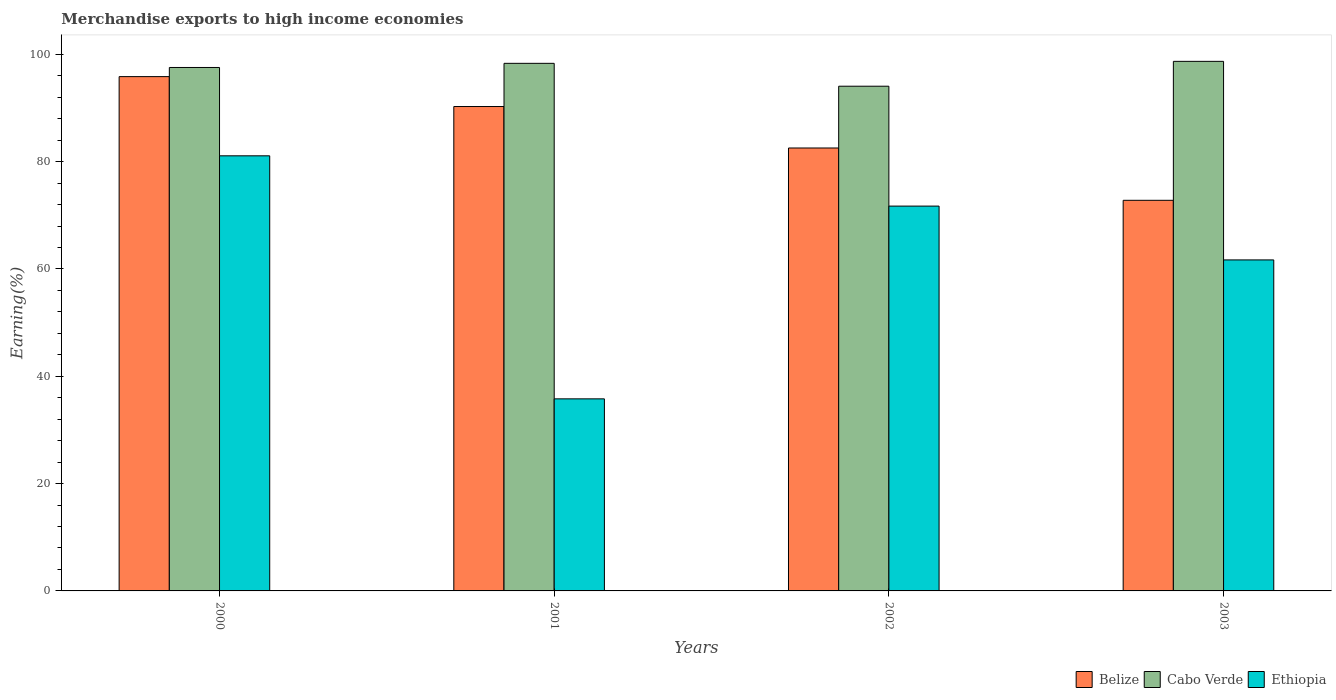Are the number of bars per tick equal to the number of legend labels?
Provide a short and direct response. Yes. What is the label of the 2nd group of bars from the left?
Ensure brevity in your answer.  2001. In how many cases, is the number of bars for a given year not equal to the number of legend labels?
Your answer should be very brief. 0. What is the percentage of amount earned from merchandise exports in Belize in 2002?
Ensure brevity in your answer.  82.54. Across all years, what is the maximum percentage of amount earned from merchandise exports in Belize?
Provide a short and direct response. 95.84. Across all years, what is the minimum percentage of amount earned from merchandise exports in Cabo Verde?
Keep it short and to the point. 94.05. What is the total percentage of amount earned from merchandise exports in Ethiopia in the graph?
Your response must be concise. 250.26. What is the difference between the percentage of amount earned from merchandise exports in Cabo Verde in 2001 and that in 2002?
Keep it short and to the point. 4.26. What is the difference between the percentage of amount earned from merchandise exports in Cabo Verde in 2000 and the percentage of amount earned from merchandise exports in Belize in 2001?
Give a very brief answer. 7.28. What is the average percentage of amount earned from merchandise exports in Belize per year?
Your answer should be compact. 85.36. In the year 2000, what is the difference between the percentage of amount earned from merchandise exports in Cabo Verde and percentage of amount earned from merchandise exports in Ethiopia?
Your response must be concise. 16.46. What is the ratio of the percentage of amount earned from merchandise exports in Cabo Verde in 2000 to that in 2003?
Give a very brief answer. 0.99. What is the difference between the highest and the second highest percentage of amount earned from merchandise exports in Ethiopia?
Make the answer very short. 9.37. What is the difference between the highest and the lowest percentage of amount earned from merchandise exports in Cabo Verde?
Offer a very short reply. 4.63. In how many years, is the percentage of amount earned from merchandise exports in Belize greater than the average percentage of amount earned from merchandise exports in Belize taken over all years?
Provide a succinct answer. 2. What does the 2nd bar from the left in 2003 represents?
Make the answer very short. Cabo Verde. What does the 1st bar from the right in 2001 represents?
Offer a very short reply. Ethiopia. Are all the bars in the graph horizontal?
Make the answer very short. No. Does the graph contain any zero values?
Offer a terse response. No. Does the graph contain grids?
Make the answer very short. No. Where does the legend appear in the graph?
Your answer should be compact. Bottom right. How are the legend labels stacked?
Offer a terse response. Horizontal. What is the title of the graph?
Give a very brief answer. Merchandise exports to high income economies. Does "Antigua and Barbuda" appear as one of the legend labels in the graph?
Offer a terse response. No. What is the label or title of the X-axis?
Your answer should be very brief. Years. What is the label or title of the Y-axis?
Provide a succinct answer. Earning(%). What is the Earning(%) of Belize in 2000?
Ensure brevity in your answer.  95.84. What is the Earning(%) of Cabo Verde in 2000?
Offer a terse response. 97.54. What is the Earning(%) of Ethiopia in 2000?
Offer a terse response. 81.08. What is the Earning(%) of Belize in 2001?
Give a very brief answer. 90.27. What is the Earning(%) of Cabo Verde in 2001?
Ensure brevity in your answer.  98.31. What is the Earning(%) of Ethiopia in 2001?
Keep it short and to the point. 35.79. What is the Earning(%) in Belize in 2002?
Offer a terse response. 82.54. What is the Earning(%) of Cabo Verde in 2002?
Offer a very short reply. 94.05. What is the Earning(%) in Ethiopia in 2002?
Your answer should be compact. 71.71. What is the Earning(%) in Belize in 2003?
Make the answer very short. 72.79. What is the Earning(%) of Cabo Verde in 2003?
Offer a terse response. 98.68. What is the Earning(%) of Ethiopia in 2003?
Provide a short and direct response. 61.68. Across all years, what is the maximum Earning(%) in Belize?
Offer a terse response. 95.84. Across all years, what is the maximum Earning(%) in Cabo Verde?
Your answer should be compact. 98.68. Across all years, what is the maximum Earning(%) in Ethiopia?
Provide a succinct answer. 81.08. Across all years, what is the minimum Earning(%) in Belize?
Provide a short and direct response. 72.79. Across all years, what is the minimum Earning(%) of Cabo Verde?
Your response must be concise. 94.05. Across all years, what is the minimum Earning(%) in Ethiopia?
Make the answer very short. 35.79. What is the total Earning(%) in Belize in the graph?
Your answer should be very brief. 341.43. What is the total Earning(%) of Cabo Verde in the graph?
Offer a very short reply. 388.59. What is the total Earning(%) of Ethiopia in the graph?
Your response must be concise. 250.26. What is the difference between the Earning(%) in Belize in 2000 and that in 2001?
Your response must be concise. 5.57. What is the difference between the Earning(%) in Cabo Verde in 2000 and that in 2001?
Keep it short and to the point. -0.77. What is the difference between the Earning(%) in Ethiopia in 2000 and that in 2001?
Make the answer very short. 45.29. What is the difference between the Earning(%) in Belize in 2000 and that in 2002?
Offer a terse response. 13.3. What is the difference between the Earning(%) of Cabo Verde in 2000 and that in 2002?
Give a very brief answer. 3.49. What is the difference between the Earning(%) in Ethiopia in 2000 and that in 2002?
Keep it short and to the point. 9.37. What is the difference between the Earning(%) of Belize in 2000 and that in 2003?
Your response must be concise. 23.05. What is the difference between the Earning(%) in Cabo Verde in 2000 and that in 2003?
Give a very brief answer. -1.14. What is the difference between the Earning(%) in Ethiopia in 2000 and that in 2003?
Keep it short and to the point. 19.4. What is the difference between the Earning(%) of Belize in 2001 and that in 2002?
Your answer should be compact. 7.73. What is the difference between the Earning(%) in Cabo Verde in 2001 and that in 2002?
Your answer should be compact. 4.26. What is the difference between the Earning(%) of Ethiopia in 2001 and that in 2002?
Keep it short and to the point. -35.92. What is the difference between the Earning(%) in Belize in 2001 and that in 2003?
Make the answer very short. 17.48. What is the difference between the Earning(%) of Cabo Verde in 2001 and that in 2003?
Give a very brief answer. -0.37. What is the difference between the Earning(%) in Ethiopia in 2001 and that in 2003?
Keep it short and to the point. -25.89. What is the difference between the Earning(%) in Belize in 2002 and that in 2003?
Your response must be concise. 9.75. What is the difference between the Earning(%) of Cabo Verde in 2002 and that in 2003?
Your answer should be very brief. -4.63. What is the difference between the Earning(%) of Ethiopia in 2002 and that in 2003?
Offer a very short reply. 10.03. What is the difference between the Earning(%) of Belize in 2000 and the Earning(%) of Cabo Verde in 2001?
Keep it short and to the point. -2.47. What is the difference between the Earning(%) in Belize in 2000 and the Earning(%) in Ethiopia in 2001?
Your response must be concise. 60.05. What is the difference between the Earning(%) in Cabo Verde in 2000 and the Earning(%) in Ethiopia in 2001?
Offer a terse response. 61.75. What is the difference between the Earning(%) of Belize in 2000 and the Earning(%) of Cabo Verde in 2002?
Your response must be concise. 1.79. What is the difference between the Earning(%) in Belize in 2000 and the Earning(%) in Ethiopia in 2002?
Your response must be concise. 24.13. What is the difference between the Earning(%) of Cabo Verde in 2000 and the Earning(%) of Ethiopia in 2002?
Offer a terse response. 25.83. What is the difference between the Earning(%) of Belize in 2000 and the Earning(%) of Cabo Verde in 2003?
Provide a succinct answer. -2.84. What is the difference between the Earning(%) of Belize in 2000 and the Earning(%) of Ethiopia in 2003?
Give a very brief answer. 34.16. What is the difference between the Earning(%) of Cabo Verde in 2000 and the Earning(%) of Ethiopia in 2003?
Your answer should be compact. 35.86. What is the difference between the Earning(%) in Belize in 2001 and the Earning(%) in Cabo Verde in 2002?
Your answer should be very brief. -3.79. What is the difference between the Earning(%) in Belize in 2001 and the Earning(%) in Ethiopia in 2002?
Make the answer very short. 18.56. What is the difference between the Earning(%) in Cabo Verde in 2001 and the Earning(%) in Ethiopia in 2002?
Provide a succinct answer. 26.6. What is the difference between the Earning(%) of Belize in 2001 and the Earning(%) of Cabo Verde in 2003?
Provide a succinct answer. -8.42. What is the difference between the Earning(%) in Belize in 2001 and the Earning(%) in Ethiopia in 2003?
Make the answer very short. 28.59. What is the difference between the Earning(%) in Cabo Verde in 2001 and the Earning(%) in Ethiopia in 2003?
Your answer should be very brief. 36.63. What is the difference between the Earning(%) in Belize in 2002 and the Earning(%) in Cabo Verde in 2003?
Your answer should be compact. -16.14. What is the difference between the Earning(%) in Belize in 2002 and the Earning(%) in Ethiopia in 2003?
Provide a succinct answer. 20.86. What is the difference between the Earning(%) in Cabo Verde in 2002 and the Earning(%) in Ethiopia in 2003?
Ensure brevity in your answer.  32.37. What is the average Earning(%) of Belize per year?
Make the answer very short. 85.36. What is the average Earning(%) of Cabo Verde per year?
Your response must be concise. 97.15. What is the average Earning(%) in Ethiopia per year?
Make the answer very short. 62.57. In the year 2000, what is the difference between the Earning(%) in Belize and Earning(%) in Cabo Verde?
Provide a succinct answer. -1.7. In the year 2000, what is the difference between the Earning(%) in Belize and Earning(%) in Ethiopia?
Your answer should be very brief. 14.76. In the year 2000, what is the difference between the Earning(%) in Cabo Verde and Earning(%) in Ethiopia?
Make the answer very short. 16.46. In the year 2001, what is the difference between the Earning(%) of Belize and Earning(%) of Cabo Verde?
Keep it short and to the point. -8.05. In the year 2001, what is the difference between the Earning(%) in Belize and Earning(%) in Ethiopia?
Provide a short and direct response. 54.48. In the year 2001, what is the difference between the Earning(%) of Cabo Verde and Earning(%) of Ethiopia?
Give a very brief answer. 62.52. In the year 2002, what is the difference between the Earning(%) in Belize and Earning(%) in Cabo Verde?
Your answer should be compact. -11.51. In the year 2002, what is the difference between the Earning(%) in Belize and Earning(%) in Ethiopia?
Offer a very short reply. 10.83. In the year 2002, what is the difference between the Earning(%) of Cabo Verde and Earning(%) of Ethiopia?
Offer a very short reply. 22.34. In the year 2003, what is the difference between the Earning(%) in Belize and Earning(%) in Cabo Verde?
Offer a terse response. -25.89. In the year 2003, what is the difference between the Earning(%) of Belize and Earning(%) of Ethiopia?
Provide a short and direct response. 11.11. In the year 2003, what is the difference between the Earning(%) of Cabo Verde and Earning(%) of Ethiopia?
Ensure brevity in your answer.  37. What is the ratio of the Earning(%) in Belize in 2000 to that in 2001?
Your answer should be very brief. 1.06. What is the ratio of the Earning(%) of Ethiopia in 2000 to that in 2001?
Provide a short and direct response. 2.27. What is the ratio of the Earning(%) of Belize in 2000 to that in 2002?
Offer a very short reply. 1.16. What is the ratio of the Earning(%) of Cabo Verde in 2000 to that in 2002?
Offer a very short reply. 1.04. What is the ratio of the Earning(%) of Ethiopia in 2000 to that in 2002?
Your answer should be compact. 1.13. What is the ratio of the Earning(%) of Belize in 2000 to that in 2003?
Your answer should be compact. 1.32. What is the ratio of the Earning(%) of Cabo Verde in 2000 to that in 2003?
Your answer should be compact. 0.99. What is the ratio of the Earning(%) in Ethiopia in 2000 to that in 2003?
Provide a short and direct response. 1.31. What is the ratio of the Earning(%) in Belize in 2001 to that in 2002?
Give a very brief answer. 1.09. What is the ratio of the Earning(%) in Cabo Verde in 2001 to that in 2002?
Keep it short and to the point. 1.05. What is the ratio of the Earning(%) in Ethiopia in 2001 to that in 2002?
Your answer should be very brief. 0.5. What is the ratio of the Earning(%) of Belize in 2001 to that in 2003?
Your answer should be compact. 1.24. What is the ratio of the Earning(%) of Cabo Verde in 2001 to that in 2003?
Make the answer very short. 1. What is the ratio of the Earning(%) of Ethiopia in 2001 to that in 2003?
Provide a succinct answer. 0.58. What is the ratio of the Earning(%) in Belize in 2002 to that in 2003?
Provide a short and direct response. 1.13. What is the ratio of the Earning(%) of Cabo Verde in 2002 to that in 2003?
Your response must be concise. 0.95. What is the ratio of the Earning(%) in Ethiopia in 2002 to that in 2003?
Keep it short and to the point. 1.16. What is the difference between the highest and the second highest Earning(%) of Belize?
Provide a succinct answer. 5.57. What is the difference between the highest and the second highest Earning(%) of Cabo Verde?
Provide a succinct answer. 0.37. What is the difference between the highest and the second highest Earning(%) in Ethiopia?
Provide a short and direct response. 9.37. What is the difference between the highest and the lowest Earning(%) of Belize?
Keep it short and to the point. 23.05. What is the difference between the highest and the lowest Earning(%) in Cabo Verde?
Offer a very short reply. 4.63. What is the difference between the highest and the lowest Earning(%) of Ethiopia?
Keep it short and to the point. 45.29. 